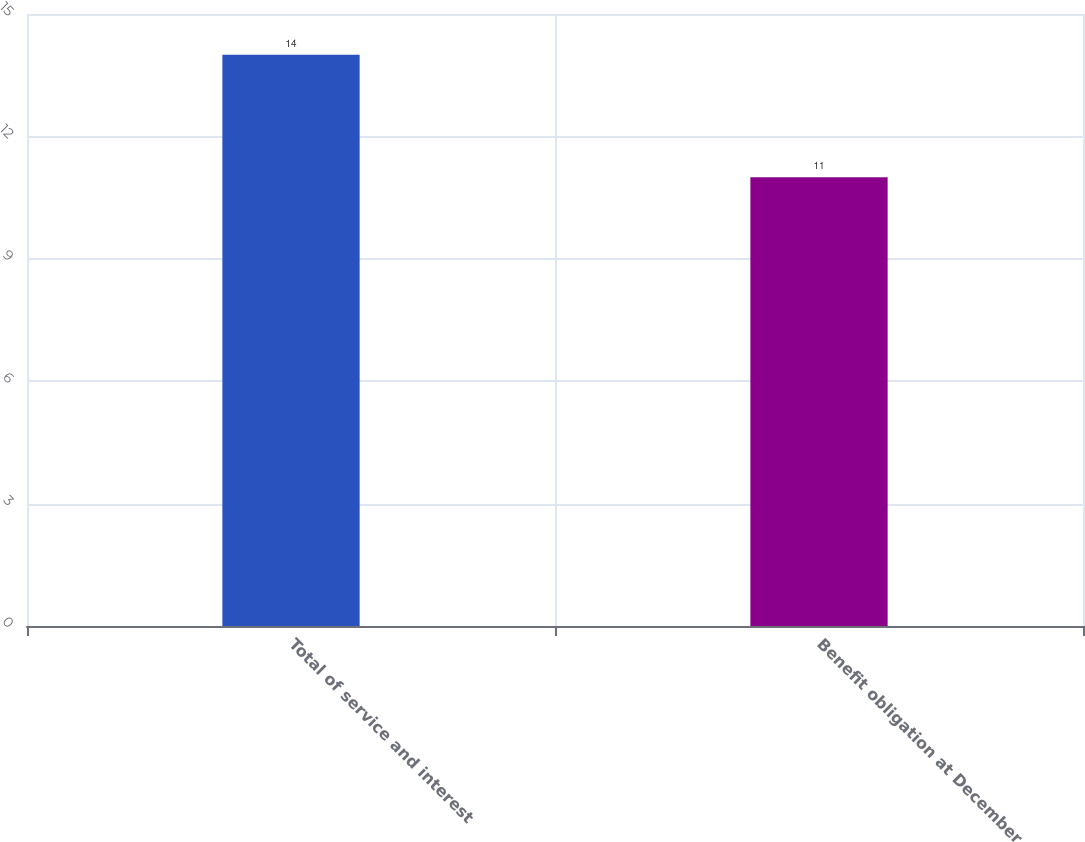Convert chart to OTSL. <chart><loc_0><loc_0><loc_500><loc_500><bar_chart><fcel>Total of service and interest<fcel>Benefit obligation at December<nl><fcel>14<fcel>11<nl></chart> 